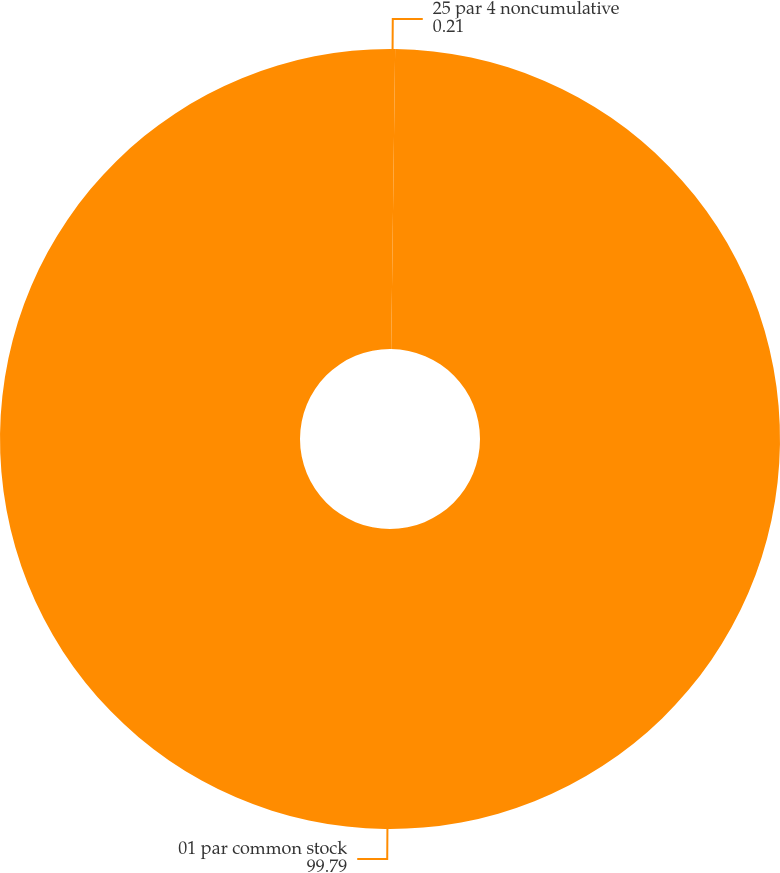Convert chart. <chart><loc_0><loc_0><loc_500><loc_500><pie_chart><fcel>25 par 4 noncumulative<fcel>01 par common stock<nl><fcel>0.21%<fcel>99.79%<nl></chart> 